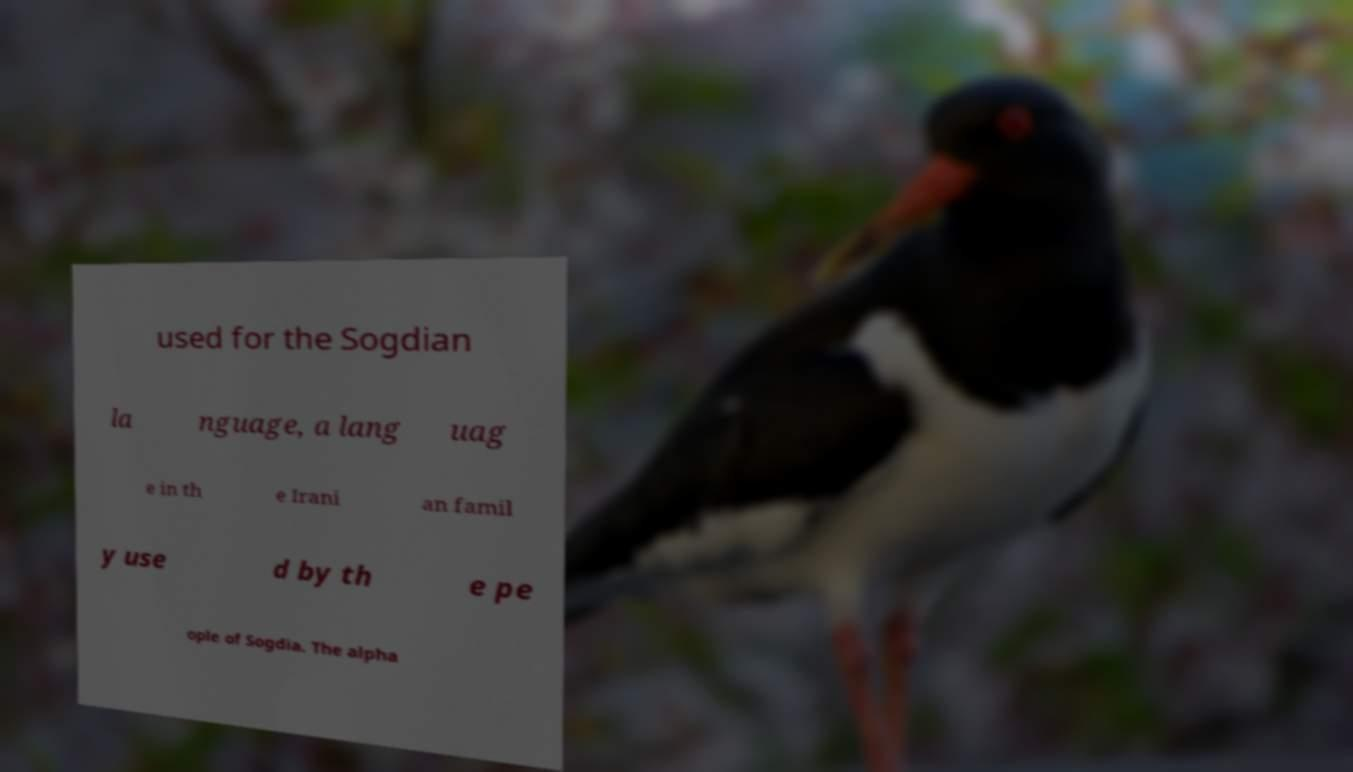There's text embedded in this image that I need extracted. Can you transcribe it verbatim? used for the Sogdian la nguage, a lang uag e in th e Irani an famil y use d by th e pe ople of Sogdia. The alpha 